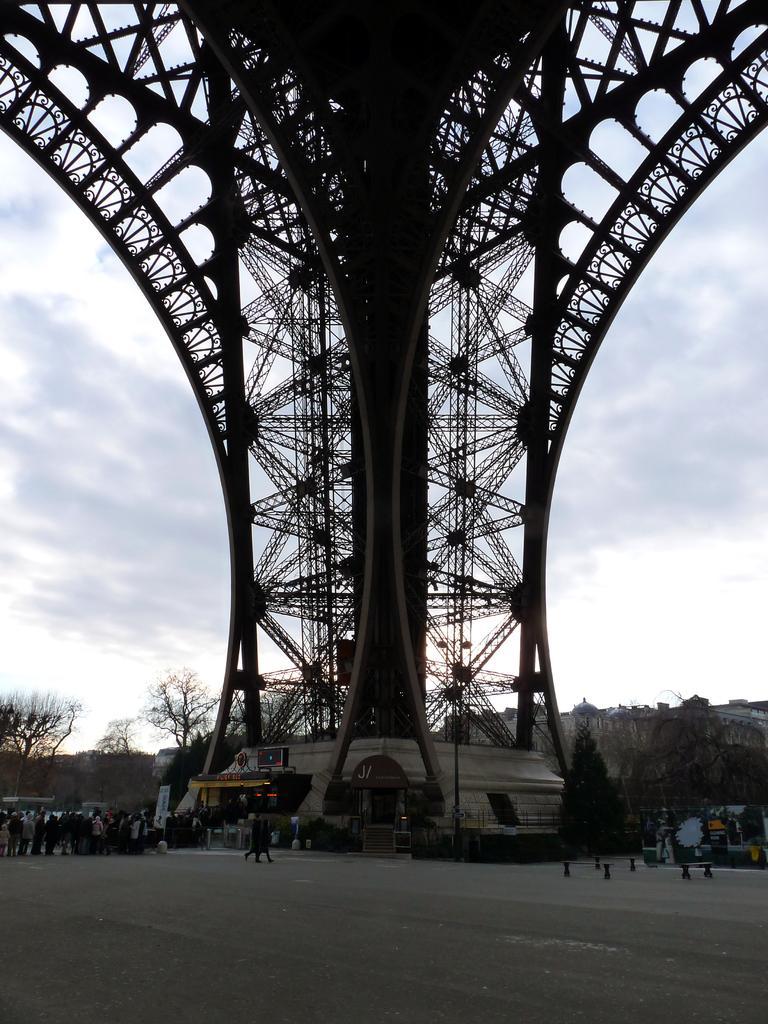Describe this image in one or two sentences. In this image, we can see a tower and in the background, there are trees, people. At the bottom, there is road. 